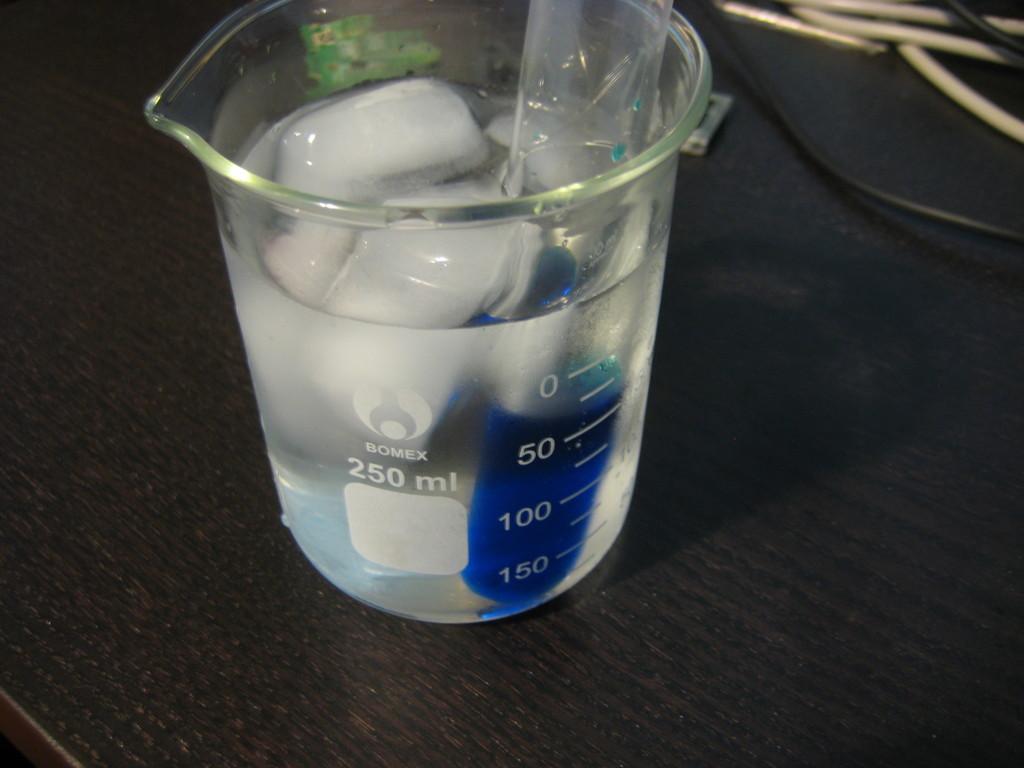How many ml in this cup?
Offer a terse response. 250. What is the brand of the cup?
Offer a terse response. Bomex. 